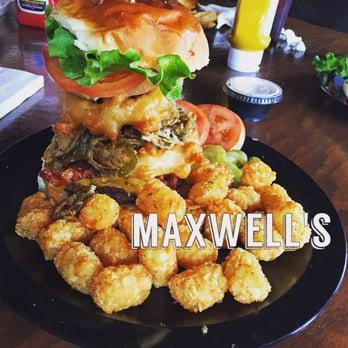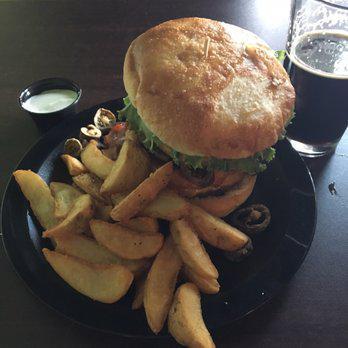The first image is the image on the left, the second image is the image on the right. Considering the images on both sides, is "There are two burgers sitting on paper." valid? Answer yes or no. No. The first image is the image on the left, the second image is the image on the right. Examine the images to the left and right. Is the description "An image shows a burger next to slender french fries on a white paper in a container." accurate? Answer yes or no. No. 